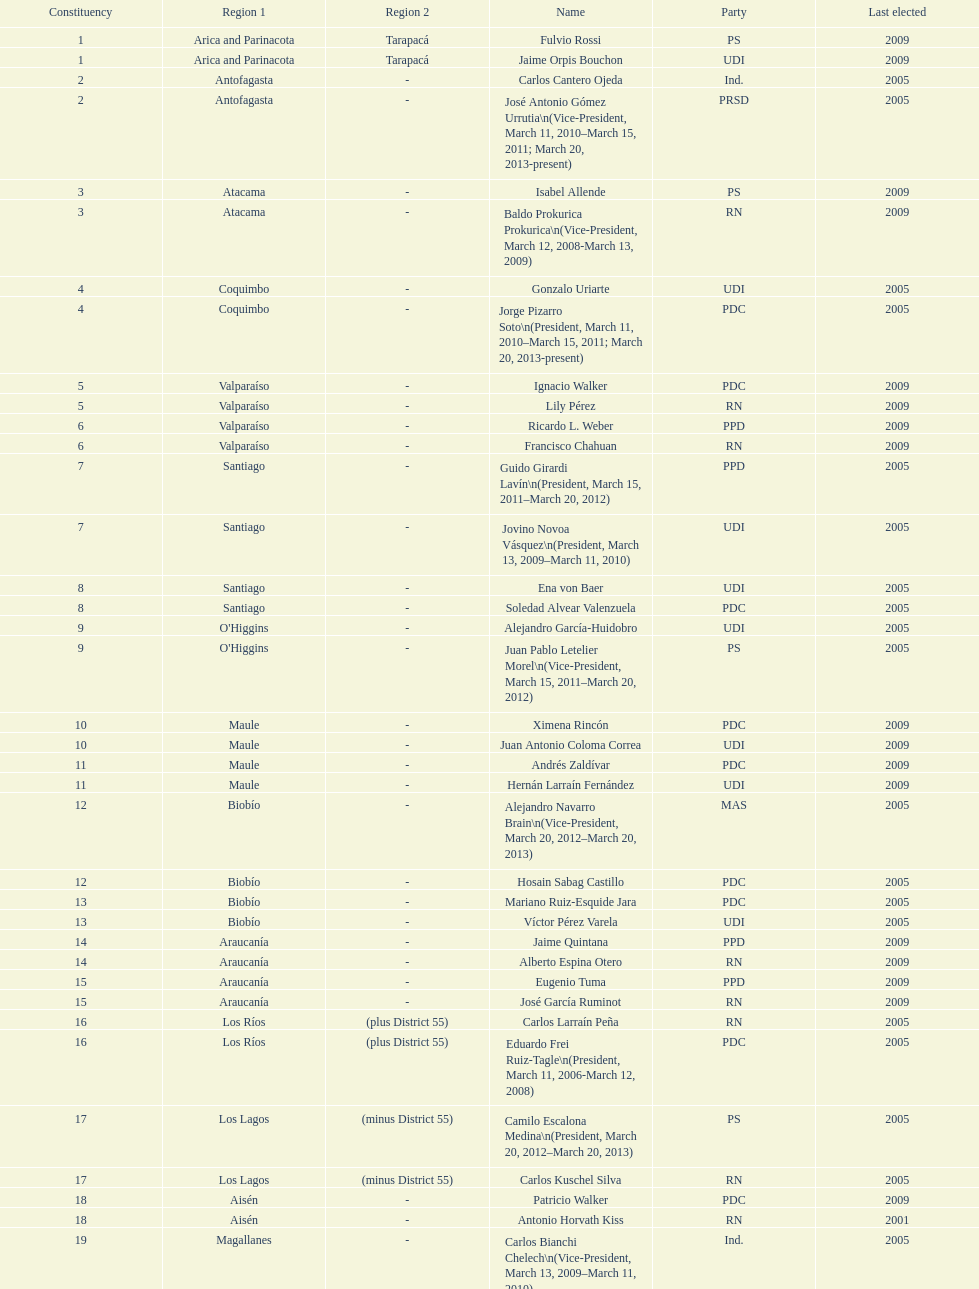Give me the full table as a dictionary. {'header': ['Constituency', 'Region 1', 'Region 2', 'Name', 'Party', 'Last elected'], 'rows': [['1', 'Arica and Parinacota', 'Tarapacá', 'Fulvio Rossi', 'PS', '2009'], ['1', 'Arica and Parinacota', 'Tarapacá', 'Jaime Orpis Bouchon', 'UDI', '2009'], ['2', 'Antofagasta', '-', 'Carlos Cantero Ojeda', 'Ind.', '2005'], ['2', 'Antofagasta', '-', 'José Antonio Gómez Urrutia\\n(Vice-President, March 11, 2010–March 15, 2011; March 20, 2013-present)', 'PRSD', '2005'], ['3', 'Atacama', '-', 'Isabel Allende', 'PS', '2009'], ['3', 'Atacama', '-', 'Baldo Prokurica Prokurica\\n(Vice-President, March 12, 2008-March 13, 2009)', 'RN', '2009'], ['4', 'Coquimbo', '-', 'Gonzalo Uriarte', 'UDI', '2005'], ['4', 'Coquimbo', '-', 'Jorge Pizarro Soto\\n(President, March 11, 2010–March 15, 2011; March 20, 2013-present)', 'PDC', '2005'], ['5', 'Valparaíso', '-', 'Ignacio Walker', 'PDC', '2009'], ['5', 'Valparaíso', '-', 'Lily Pérez', 'RN', '2009'], ['6', 'Valparaíso', '-', 'Ricardo L. Weber', 'PPD', '2009'], ['6', 'Valparaíso', '-', 'Francisco Chahuan', 'RN', '2009'], ['7', 'Santiago', '-', 'Guido Girardi Lavín\\n(President, March 15, 2011–March 20, 2012)', 'PPD', '2005'], ['7', 'Santiago', '-', 'Jovino Novoa Vásquez\\n(President, March 13, 2009–March 11, 2010)', 'UDI', '2005'], ['8', 'Santiago', '-', 'Ena von Baer', 'UDI', '2005'], ['8', 'Santiago', '-', 'Soledad Alvear Valenzuela', 'PDC', '2005'], ['9', "O'Higgins", '-', 'Alejandro García-Huidobro', 'UDI', '2005'], ['9', "O'Higgins", '-', 'Juan Pablo Letelier Morel\\n(Vice-President, March 15, 2011–March 20, 2012)', 'PS', '2005'], ['10', 'Maule', '-', 'Ximena Rincón', 'PDC', '2009'], ['10', 'Maule', '-', 'Juan Antonio Coloma Correa', 'UDI', '2009'], ['11', 'Maule', '-', 'Andrés Zaldívar', 'PDC', '2009'], ['11', 'Maule', '-', 'Hernán Larraín Fernández', 'UDI', '2009'], ['12', 'Biobío', '-', 'Alejandro Navarro Brain\\n(Vice-President, March 20, 2012–March 20, 2013)', 'MAS', '2005'], ['12', 'Biobío', '-', 'Hosain Sabag Castillo', 'PDC', '2005'], ['13', 'Biobío', '-', 'Mariano Ruiz-Esquide Jara', 'PDC', '2005'], ['13', 'Biobío', '-', 'Víctor Pérez Varela', 'UDI', '2005'], ['14', 'Araucanía', '-', 'Jaime Quintana', 'PPD', '2009'], ['14', 'Araucanía', '-', 'Alberto Espina Otero', 'RN', '2009'], ['15', 'Araucanía', '-', 'Eugenio Tuma', 'PPD', '2009'], ['15', 'Araucanía', '-', 'José García Ruminot', 'RN', '2009'], ['16', 'Los Ríos', '(plus District 55)', 'Carlos Larraín Peña', 'RN', '2005'], ['16', 'Los Ríos', '(plus District 55)', 'Eduardo Frei Ruiz-Tagle\\n(President, March 11, 2006-March 12, 2008)', 'PDC', '2005'], ['17', 'Los Lagos', '(minus District 55)', 'Camilo Escalona Medina\\n(President, March 20, 2012–March 20, 2013)', 'PS', '2005'], ['17', 'Los Lagos', '(minus District 55)', 'Carlos Kuschel Silva', 'RN', '2005'], ['18', 'Aisén', '-', 'Patricio Walker', 'PDC', '2009'], ['18', 'Aisén', '-', 'Antonio Horvath Kiss', 'RN', '2001'], ['19', 'Magallanes', '-', 'Carlos Bianchi Chelech\\n(Vice-President, March 13, 2009–March 11, 2010)', 'Ind.', '2005'], ['19', 'Magallanes', '-', 'Pedro Muñoz Aburto', 'PS', '2005']]} Which region is listed below atacama? Coquimbo. 